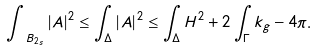<formula> <loc_0><loc_0><loc_500><loc_500>\int _ { \ B _ { 2 s } } | A | ^ { 2 } \leq \int _ { \Delta } | A | ^ { 2 } \leq \int _ { \Delta } H ^ { 2 } + 2 \int _ { \Gamma } k _ { g } - 4 \pi .</formula> 